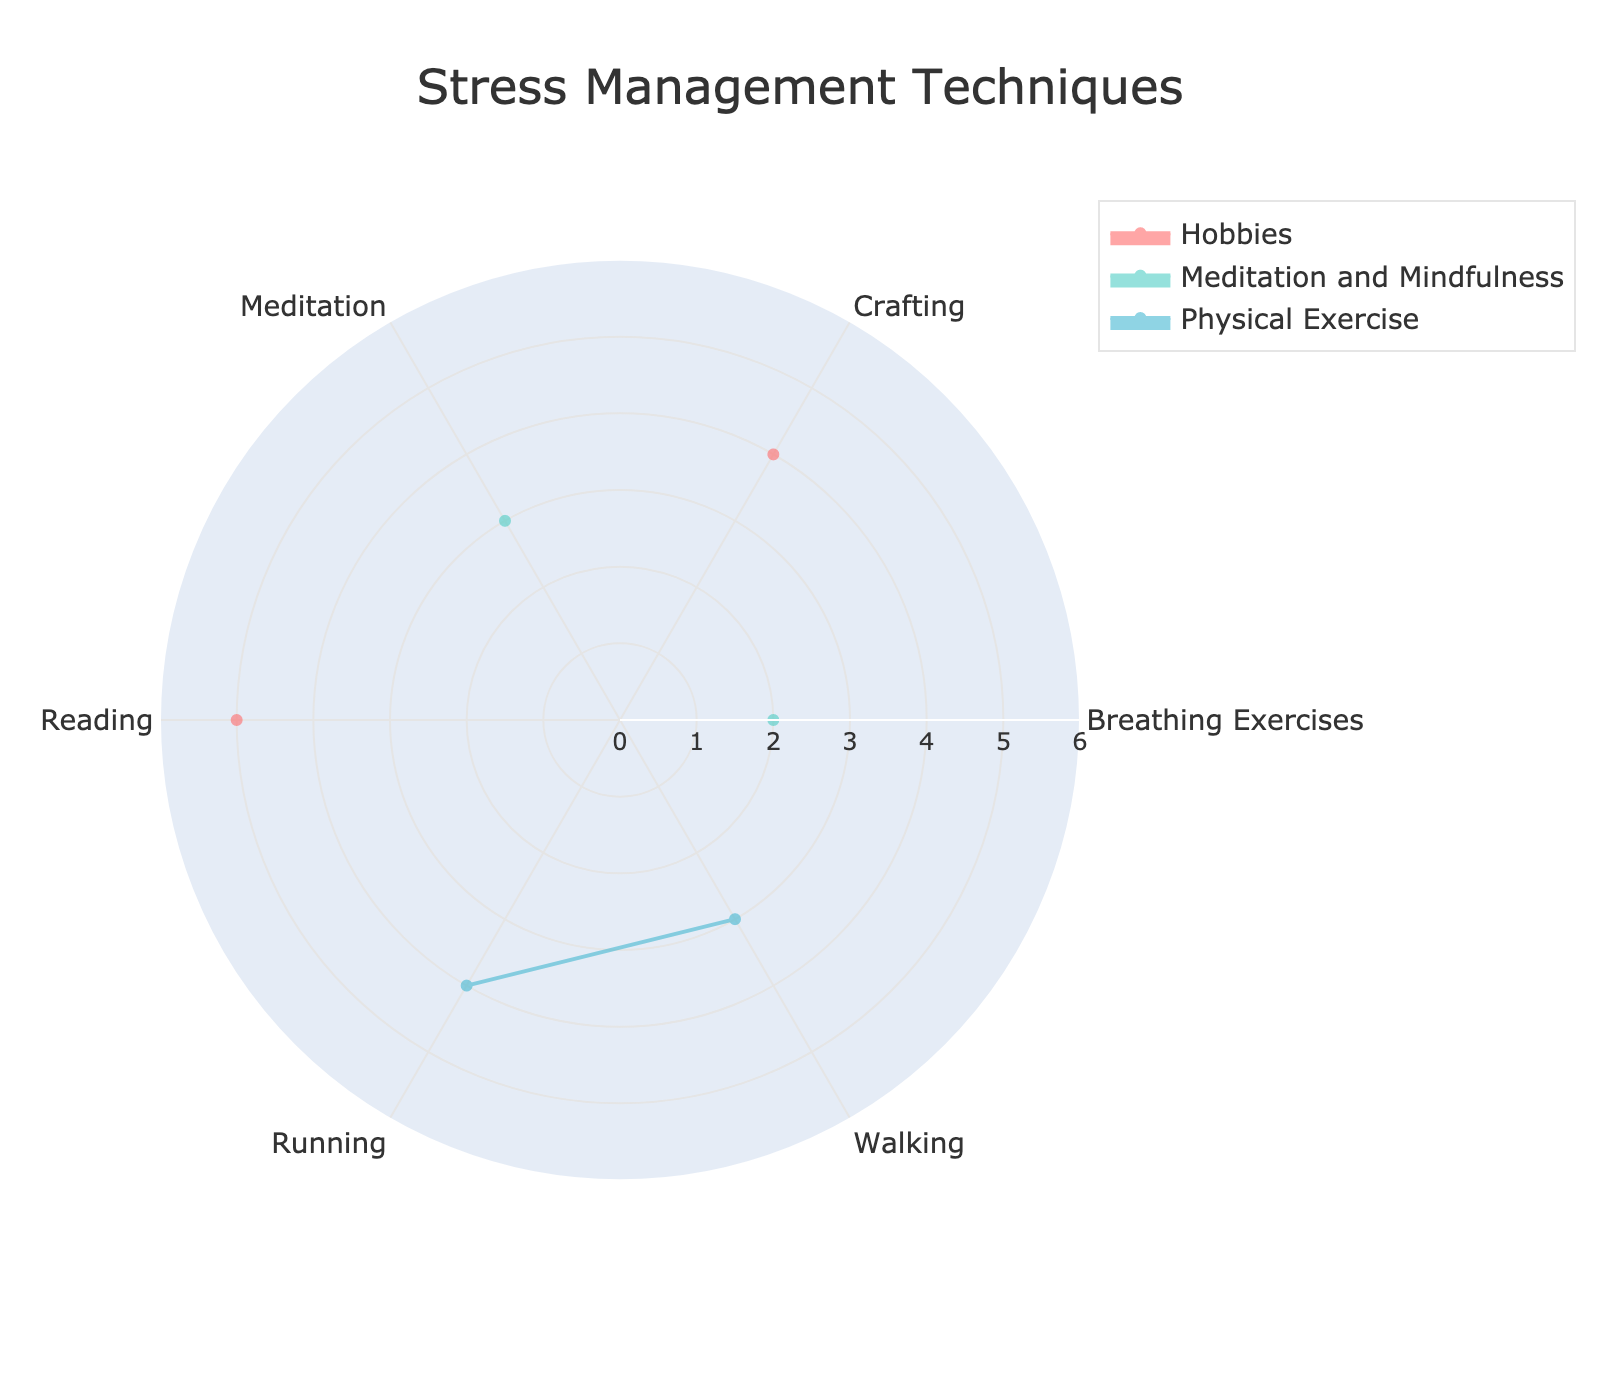What's the title of the radar chart? The title is usually displayed at the top of the chart in a larger font. Based on the description, it should indicate the main theme of the chart.
Answer: Stress Management Techniques How many groups are represented in the radar chart? Look at the legend of the radar chart, which lists all the groups whose data is shown. Each group should have its own color and name.
Answer: 3 Which group spends the most time on running? Check the 'Running' axis and see which group's plot has the highest value along that axis.
Answer: Physical Exercise Which activity does the Hobbies group spend the most time on? Focus on the plot area corresponding to the Hobbies group, and identify the highest value among the activities listed.
Answer: Reading How much time does the Meditation and Mindfulness group spend on breathing exercises? Locate the 'Breathing Exercises' axis and see the value related to the Meditation and Mindfulness group.
Answer: 2 hours per week Which activity has the highest average time spent across all groups? Calculate the total time for each activity across all groups and find the one with the maximum sum, then divide by the number of groups to get the average.
Answer: Reading Which group has the least time spent overall when combining all activities? Sum the time spent for each activity within each group. Compare these sums to find the smallest value.
Answer: Meditation and Mindfulness Compare the time spent on crafting between the Hobbies group and Physical Exercise group. Which group spends more time on this activity? Identify the values along the 'Crafting' axis for both groups, and determine which is higher.
Answer: Hobbies What is the total time spent on meditation by the Meditation and Mindfulness group and Hobbies group combined? Add the value of the time spent on 'Meditation' from both Meditation and Mindfulness and Hobbies groups.
Answer: 3 hours What's the difference in time spent on reading between the Hobbies group and Physical Exercise group? Find and subtract the time spent on 'Reading' by the Physical Exercise group from the time spent by the Hobbies group.
Answer: 5 hours 